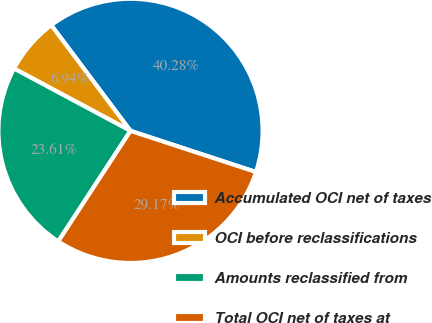<chart> <loc_0><loc_0><loc_500><loc_500><pie_chart><fcel>Accumulated OCI net of taxes<fcel>OCI before reclassifications<fcel>Amounts reclassified from<fcel>Total OCI net of taxes at<nl><fcel>40.28%<fcel>6.94%<fcel>23.61%<fcel>29.17%<nl></chart> 